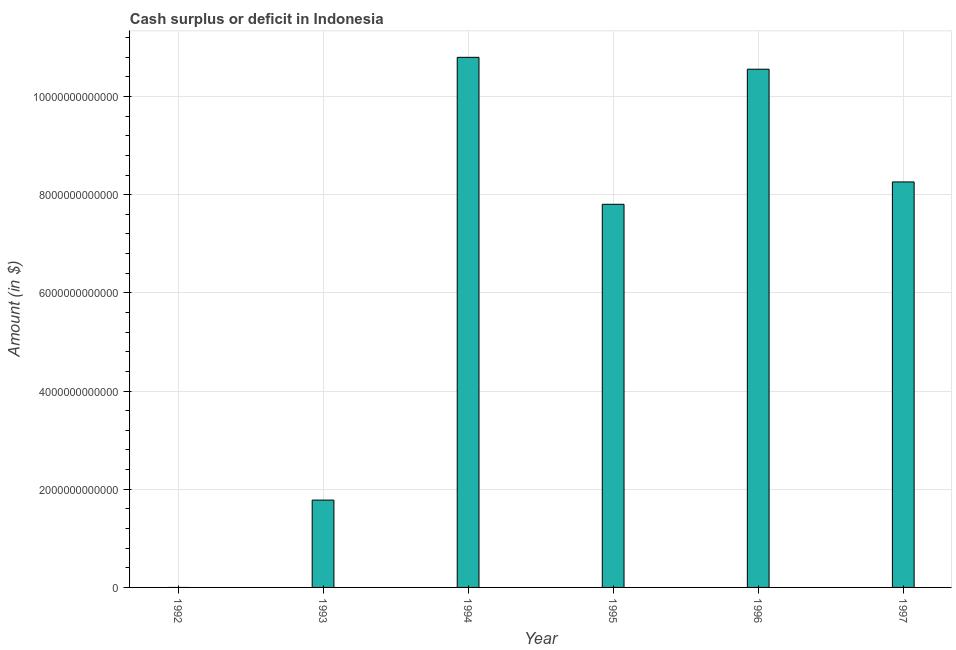Does the graph contain any zero values?
Your answer should be compact. Yes. Does the graph contain grids?
Provide a short and direct response. Yes. What is the title of the graph?
Offer a very short reply. Cash surplus or deficit in Indonesia. What is the label or title of the Y-axis?
Your answer should be compact. Amount (in $). What is the cash surplus or deficit in 1993?
Give a very brief answer. 1.78e+12. Across all years, what is the maximum cash surplus or deficit?
Offer a terse response. 1.08e+13. In which year was the cash surplus or deficit maximum?
Provide a short and direct response. 1994. What is the sum of the cash surplus or deficit?
Your answer should be very brief. 3.92e+13. What is the difference between the cash surplus or deficit in 1993 and 1994?
Provide a succinct answer. -9.02e+12. What is the average cash surplus or deficit per year?
Keep it short and to the point. 6.53e+12. What is the median cash surplus or deficit?
Your answer should be compact. 8.03e+12. What is the ratio of the cash surplus or deficit in 1995 to that in 1996?
Keep it short and to the point. 0.74. Is the cash surplus or deficit in 1993 less than that in 1995?
Make the answer very short. Yes. Is the difference between the cash surplus or deficit in 1993 and 1996 greater than the difference between any two years?
Offer a terse response. No. What is the difference between the highest and the second highest cash surplus or deficit?
Your response must be concise. 2.42e+11. What is the difference between the highest and the lowest cash surplus or deficit?
Provide a short and direct response. 1.08e+13. How many bars are there?
Give a very brief answer. 5. Are all the bars in the graph horizontal?
Ensure brevity in your answer.  No. What is the difference between two consecutive major ticks on the Y-axis?
Offer a very short reply. 2.00e+12. What is the Amount (in $) in 1992?
Your answer should be compact. 0. What is the Amount (in $) of 1993?
Ensure brevity in your answer.  1.78e+12. What is the Amount (in $) in 1994?
Provide a short and direct response. 1.08e+13. What is the Amount (in $) of 1995?
Provide a succinct answer. 7.80e+12. What is the Amount (in $) of 1996?
Your response must be concise. 1.06e+13. What is the Amount (in $) in 1997?
Keep it short and to the point. 8.26e+12. What is the difference between the Amount (in $) in 1993 and 1994?
Provide a succinct answer. -9.02e+12. What is the difference between the Amount (in $) in 1993 and 1995?
Provide a succinct answer. -6.03e+12. What is the difference between the Amount (in $) in 1993 and 1996?
Offer a terse response. -8.78e+12. What is the difference between the Amount (in $) in 1993 and 1997?
Your answer should be compact. -6.48e+12. What is the difference between the Amount (in $) in 1994 and 1995?
Give a very brief answer. 2.99e+12. What is the difference between the Amount (in $) in 1994 and 1996?
Ensure brevity in your answer.  2.42e+11. What is the difference between the Amount (in $) in 1994 and 1997?
Provide a short and direct response. 2.54e+12. What is the difference between the Amount (in $) in 1995 and 1996?
Make the answer very short. -2.75e+12. What is the difference between the Amount (in $) in 1995 and 1997?
Your answer should be compact. -4.56e+11. What is the difference between the Amount (in $) in 1996 and 1997?
Offer a terse response. 2.30e+12. What is the ratio of the Amount (in $) in 1993 to that in 1994?
Your answer should be compact. 0.17. What is the ratio of the Amount (in $) in 1993 to that in 1995?
Your answer should be compact. 0.23. What is the ratio of the Amount (in $) in 1993 to that in 1996?
Keep it short and to the point. 0.17. What is the ratio of the Amount (in $) in 1993 to that in 1997?
Make the answer very short. 0.21. What is the ratio of the Amount (in $) in 1994 to that in 1995?
Keep it short and to the point. 1.38. What is the ratio of the Amount (in $) in 1994 to that in 1996?
Offer a terse response. 1.02. What is the ratio of the Amount (in $) in 1994 to that in 1997?
Give a very brief answer. 1.31. What is the ratio of the Amount (in $) in 1995 to that in 1996?
Provide a short and direct response. 0.74. What is the ratio of the Amount (in $) in 1995 to that in 1997?
Make the answer very short. 0.94. What is the ratio of the Amount (in $) in 1996 to that in 1997?
Make the answer very short. 1.28. 